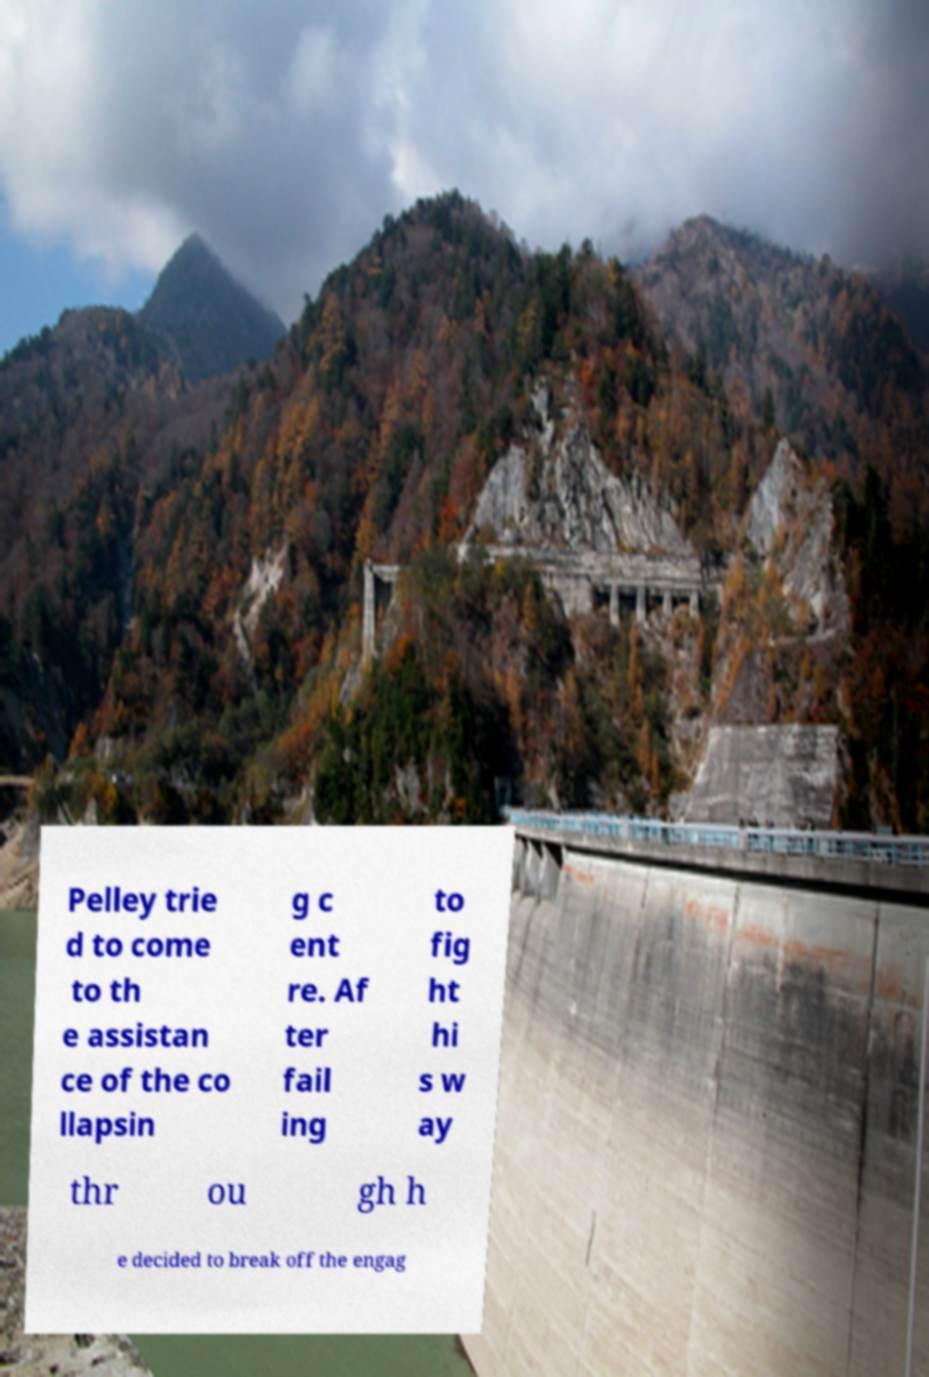Can you accurately transcribe the text from the provided image for me? Pelley trie d to come to th e assistan ce of the co llapsin g c ent re. Af ter fail ing to fig ht hi s w ay thr ou gh h e decided to break off the engag 